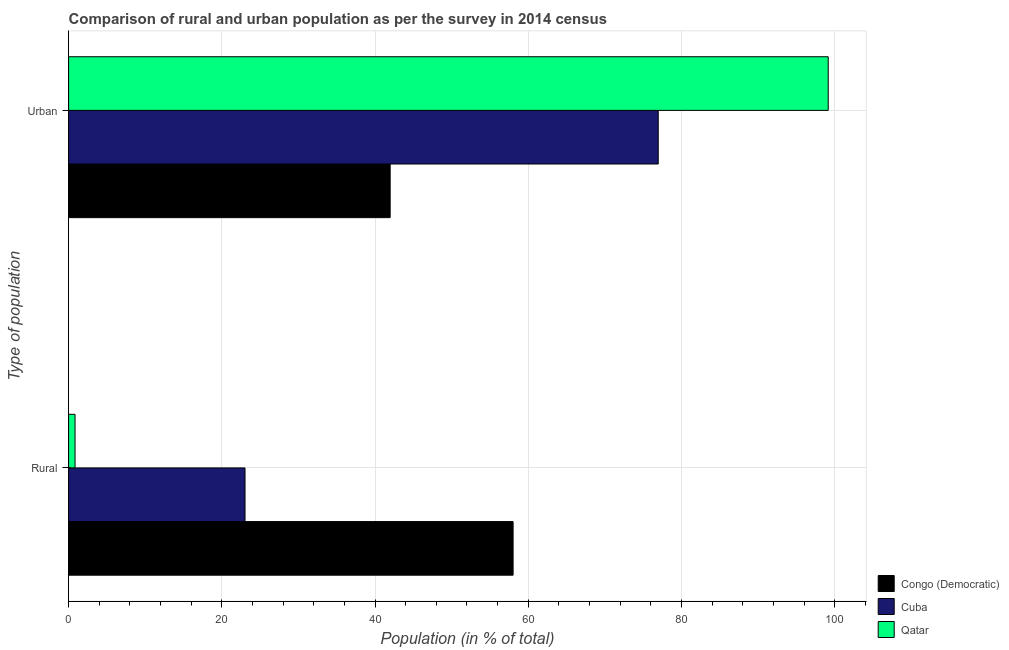Are the number of bars on each tick of the Y-axis equal?
Provide a succinct answer. Yes. How many bars are there on the 2nd tick from the bottom?
Give a very brief answer. 3. What is the label of the 1st group of bars from the top?
Make the answer very short. Urban. What is the urban population in Qatar?
Ensure brevity in your answer.  99.16. Across all countries, what is the maximum rural population?
Provide a succinct answer. 58.02. Across all countries, what is the minimum rural population?
Make the answer very short. 0.84. In which country was the rural population maximum?
Offer a very short reply. Congo (Democratic). In which country was the urban population minimum?
Your response must be concise. Congo (Democratic). What is the total rural population in the graph?
Your answer should be compact. 81.89. What is the difference between the rural population in Cuba and that in Qatar?
Give a very brief answer. 22.19. What is the difference between the rural population in Cuba and the urban population in Congo (Democratic)?
Your answer should be compact. -18.95. What is the average urban population per country?
Your answer should be very brief. 72.7. What is the difference between the rural population and urban population in Cuba?
Make the answer very short. -53.94. In how many countries, is the urban population greater than 96 %?
Offer a terse response. 1. What is the ratio of the urban population in Congo (Democratic) to that in Cuba?
Your answer should be very brief. 0.55. Is the rural population in Cuba less than that in Congo (Democratic)?
Keep it short and to the point. Yes. In how many countries, is the rural population greater than the average rural population taken over all countries?
Offer a terse response. 1. What does the 1st bar from the top in Urban represents?
Offer a terse response. Qatar. What does the 2nd bar from the bottom in Urban represents?
Keep it short and to the point. Cuba. Are all the bars in the graph horizontal?
Make the answer very short. Yes. Are the values on the major ticks of X-axis written in scientific E-notation?
Your answer should be compact. No. Does the graph contain any zero values?
Provide a short and direct response. No. Does the graph contain grids?
Provide a short and direct response. Yes. Where does the legend appear in the graph?
Your response must be concise. Bottom right. How are the legend labels stacked?
Your answer should be very brief. Vertical. What is the title of the graph?
Give a very brief answer. Comparison of rural and urban population as per the survey in 2014 census. Does "United Kingdom" appear as one of the legend labels in the graph?
Offer a terse response. No. What is the label or title of the X-axis?
Offer a very short reply. Population (in % of total). What is the label or title of the Y-axis?
Ensure brevity in your answer.  Type of population. What is the Population (in % of total) of Congo (Democratic) in Rural?
Ensure brevity in your answer.  58.02. What is the Population (in % of total) of Cuba in Rural?
Keep it short and to the point. 23.03. What is the Population (in % of total) of Qatar in Rural?
Make the answer very short. 0.84. What is the Population (in % of total) in Congo (Democratic) in Urban?
Your response must be concise. 41.98. What is the Population (in % of total) in Cuba in Urban?
Provide a succinct answer. 76.97. What is the Population (in % of total) of Qatar in Urban?
Your response must be concise. 99.16. Across all Type of population, what is the maximum Population (in % of total) in Congo (Democratic)?
Keep it short and to the point. 58.02. Across all Type of population, what is the maximum Population (in % of total) of Cuba?
Provide a succinct answer. 76.97. Across all Type of population, what is the maximum Population (in % of total) in Qatar?
Keep it short and to the point. 99.16. Across all Type of population, what is the minimum Population (in % of total) in Congo (Democratic)?
Your answer should be very brief. 41.98. Across all Type of population, what is the minimum Population (in % of total) of Cuba?
Your answer should be compact. 23.03. Across all Type of population, what is the minimum Population (in % of total) of Qatar?
Your answer should be very brief. 0.84. What is the total Population (in % of total) of Cuba in the graph?
Provide a short and direct response. 100. What is the difference between the Population (in % of total) of Congo (Democratic) in Rural and that in Urban?
Your response must be concise. 16.05. What is the difference between the Population (in % of total) in Cuba in Rural and that in Urban?
Offer a very short reply. -53.94. What is the difference between the Population (in % of total) in Qatar in Rural and that in Urban?
Your response must be concise. -98.32. What is the difference between the Population (in % of total) in Congo (Democratic) in Rural and the Population (in % of total) in Cuba in Urban?
Your answer should be very brief. -18.95. What is the difference between the Population (in % of total) of Congo (Democratic) in Rural and the Population (in % of total) of Qatar in Urban?
Offer a very short reply. -41.13. What is the difference between the Population (in % of total) in Cuba in Rural and the Population (in % of total) in Qatar in Urban?
Your response must be concise. -76.13. What is the average Population (in % of total) of Qatar per Type of population?
Ensure brevity in your answer.  50. What is the difference between the Population (in % of total) in Congo (Democratic) and Population (in % of total) in Cuba in Rural?
Make the answer very short. 34.99. What is the difference between the Population (in % of total) of Congo (Democratic) and Population (in % of total) of Qatar in Rural?
Offer a very short reply. 57.18. What is the difference between the Population (in % of total) in Cuba and Population (in % of total) in Qatar in Rural?
Provide a succinct answer. 22.19. What is the difference between the Population (in % of total) of Congo (Democratic) and Population (in % of total) of Cuba in Urban?
Offer a very short reply. -34.99. What is the difference between the Population (in % of total) in Congo (Democratic) and Population (in % of total) in Qatar in Urban?
Offer a very short reply. -57.18. What is the difference between the Population (in % of total) of Cuba and Population (in % of total) of Qatar in Urban?
Your answer should be very brief. -22.19. What is the ratio of the Population (in % of total) of Congo (Democratic) in Rural to that in Urban?
Provide a succinct answer. 1.38. What is the ratio of the Population (in % of total) in Cuba in Rural to that in Urban?
Your answer should be compact. 0.3. What is the ratio of the Population (in % of total) in Qatar in Rural to that in Urban?
Offer a terse response. 0.01. What is the difference between the highest and the second highest Population (in % of total) of Congo (Democratic)?
Your answer should be compact. 16.05. What is the difference between the highest and the second highest Population (in % of total) of Cuba?
Keep it short and to the point. 53.94. What is the difference between the highest and the second highest Population (in % of total) of Qatar?
Your answer should be compact. 98.32. What is the difference between the highest and the lowest Population (in % of total) in Congo (Democratic)?
Provide a short and direct response. 16.05. What is the difference between the highest and the lowest Population (in % of total) in Cuba?
Keep it short and to the point. 53.94. What is the difference between the highest and the lowest Population (in % of total) of Qatar?
Offer a terse response. 98.32. 